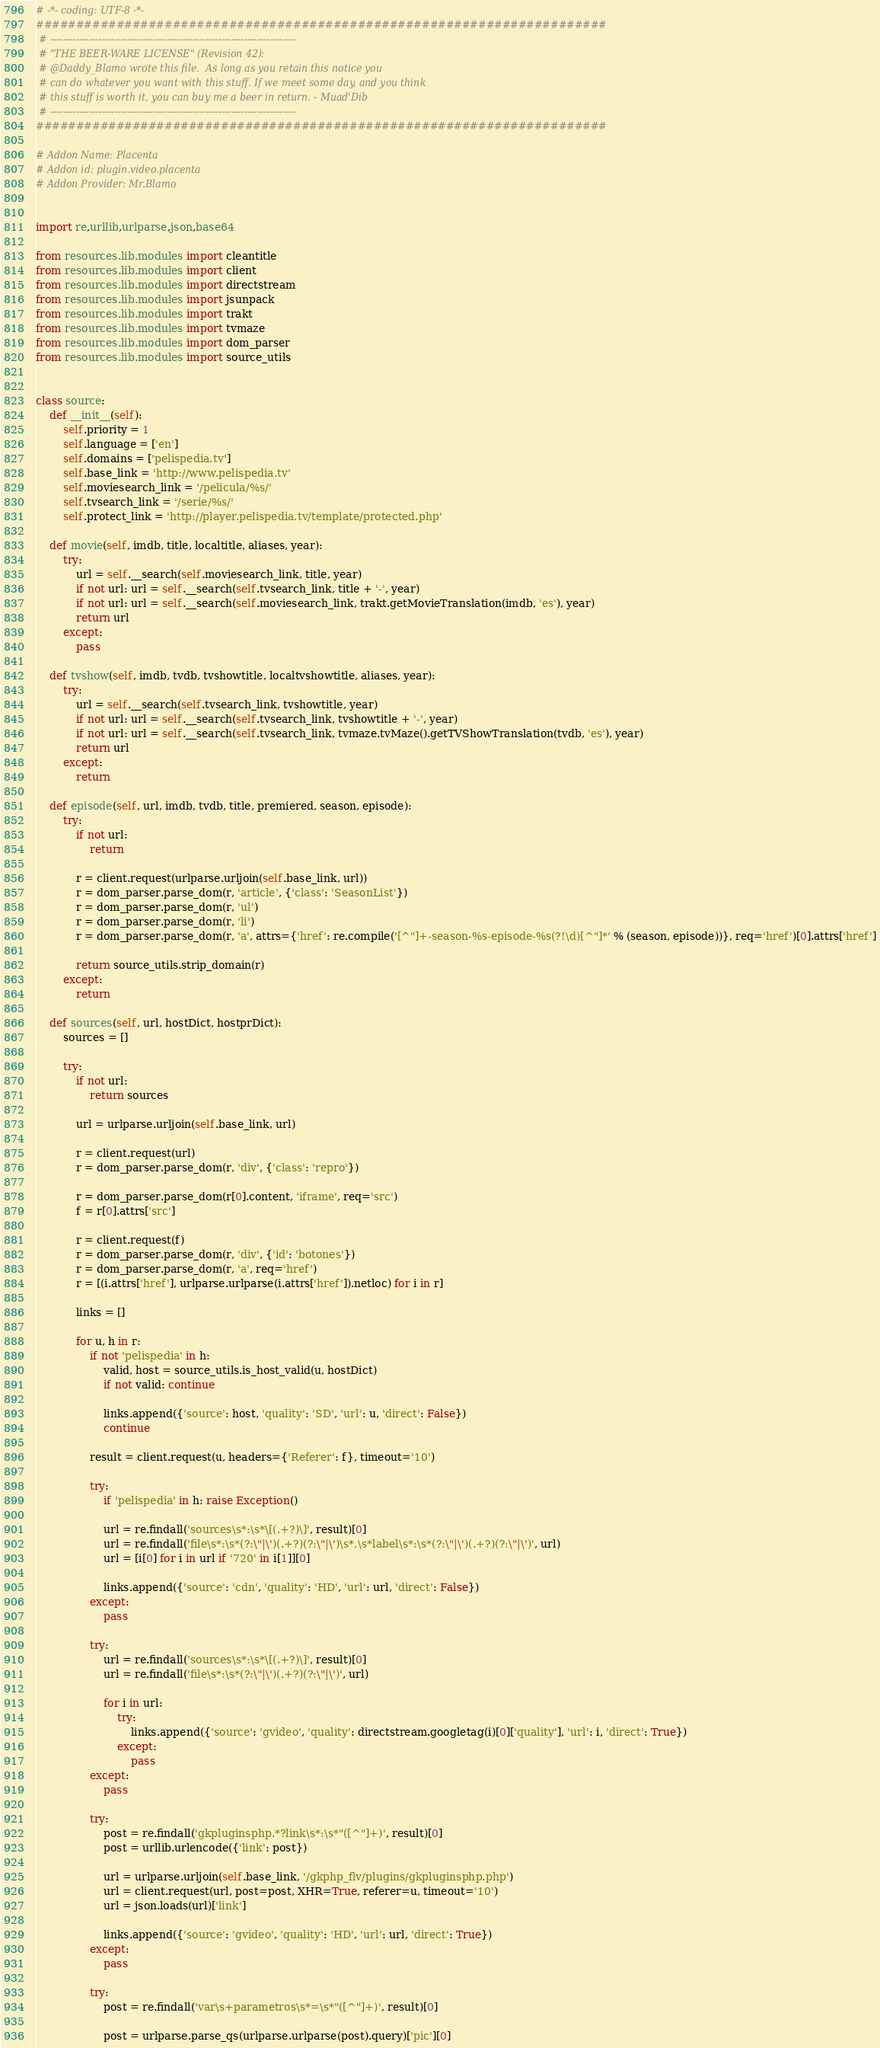Convert code to text. <code><loc_0><loc_0><loc_500><loc_500><_Python_># -*- coding: UTF-8 -*-
#######################################################################
 # ----------------------------------------------------------------------------
 # "THE BEER-WARE LICENSE" (Revision 42):
 # @Daddy_Blamo wrote this file.  As long as you retain this notice you
 # can do whatever you want with this stuff. If we meet some day, and you think
 # this stuff is worth it, you can buy me a beer in return. - Muad'Dib
 # ----------------------------------------------------------------------------
#######################################################################

# Addon Name: Placenta
# Addon id: plugin.video.placenta
# Addon Provider: Mr.Blamo


import re,urllib,urlparse,json,base64

from resources.lib.modules import cleantitle
from resources.lib.modules import client
from resources.lib.modules import directstream
from resources.lib.modules import jsunpack
from resources.lib.modules import trakt
from resources.lib.modules import tvmaze
from resources.lib.modules import dom_parser
from resources.lib.modules import source_utils


class source:
    def __init__(self):
        self.priority = 1
        self.language = ['en']
        self.domains = ['pelispedia.tv']
        self.base_link = 'http://www.pelispedia.tv'
        self.moviesearch_link = '/pelicula/%s/'
        self.tvsearch_link = '/serie/%s/'
        self.protect_link = 'http://player.pelispedia.tv/template/protected.php'

    def movie(self, imdb, title, localtitle, aliases, year):
        try:
            url = self.__search(self.moviesearch_link, title, year)
            if not url: url = self.__search(self.tvsearch_link, title + '-', year)
            if not url: url = self.__search(self.moviesearch_link, trakt.getMovieTranslation(imdb, 'es'), year)
            return url
        except:
            pass

    def tvshow(self, imdb, tvdb, tvshowtitle, localtvshowtitle, aliases, year):
        try:
            url = self.__search(self.tvsearch_link, tvshowtitle, year)
            if not url: url = self.__search(self.tvsearch_link, tvshowtitle + '-', year)
            if not url: url = self.__search(self.tvsearch_link, tvmaze.tvMaze().getTVShowTranslation(tvdb, 'es'), year)
            return url
        except:
            return

    def episode(self, url, imdb, tvdb, title, premiered, season, episode):
        try:
            if not url:
                return

            r = client.request(urlparse.urljoin(self.base_link, url))
            r = dom_parser.parse_dom(r, 'article', {'class': 'SeasonList'})
            r = dom_parser.parse_dom(r, 'ul')
            r = dom_parser.parse_dom(r, 'li')
            r = dom_parser.parse_dom(r, 'a', attrs={'href': re.compile('[^"]+-season-%s-episode-%s(?!\d)[^"]*' % (season, episode))}, req='href')[0].attrs['href']

            return source_utils.strip_domain(r)
        except:
            return

    def sources(self, url, hostDict, hostprDict):
        sources = []

        try:
            if not url:
                return sources

            url = urlparse.urljoin(self.base_link, url)

            r = client.request(url)
            r = dom_parser.parse_dom(r, 'div', {'class': 'repro'})

            r = dom_parser.parse_dom(r[0].content, 'iframe', req='src')
            f = r[0].attrs['src']

            r = client.request(f)
            r = dom_parser.parse_dom(r, 'div', {'id': 'botones'})
            r = dom_parser.parse_dom(r, 'a', req='href')
            r = [(i.attrs['href'], urlparse.urlparse(i.attrs['href']).netloc) for i in r]

            links = []

            for u, h in r:
                if not 'pelispedia' in h:
                    valid, host = source_utils.is_host_valid(u, hostDict)
                    if not valid: continue

                    links.append({'source': host, 'quality': 'SD', 'url': u, 'direct': False})
                    continue

                result = client.request(u, headers={'Referer': f}, timeout='10')

                try:
                    if 'pelispedia' in h: raise Exception()

                    url = re.findall('sources\s*:\s*\[(.+?)\]', result)[0]
                    url = re.findall('file\s*:\s*(?:\"|\')(.+?)(?:\"|\')\s*,\s*label\s*:\s*(?:\"|\')(.+?)(?:\"|\')', url)
                    url = [i[0] for i in url if '720' in i[1]][0]

                    links.append({'source': 'cdn', 'quality': 'HD', 'url': url, 'direct': False})
                except:
                    pass

                try:
                    url = re.findall('sources\s*:\s*\[(.+?)\]', result)[0]
                    url = re.findall('file\s*:\s*(?:\"|\')(.+?)(?:\"|\')', url)

                    for i in url:
                        try:
                            links.append({'source': 'gvideo', 'quality': directstream.googletag(i)[0]['quality'], 'url': i, 'direct': True})
                        except:
                            pass
                except:
                    pass

                try:
                    post = re.findall('gkpluginsphp.*?link\s*:\s*"([^"]+)', result)[0]
                    post = urllib.urlencode({'link': post})

                    url = urlparse.urljoin(self.base_link, '/gkphp_flv/plugins/gkpluginsphp.php')
                    url = client.request(url, post=post, XHR=True, referer=u, timeout='10')
                    url = json.loads(url)['link']

                    links.append({'source': 'gvideo', 'quality': 'HD', 'url': url, 'direct': True})
                except:
                    pass

                try:
                    post = re.findall('var\s+parametros\s*=\s*"([^"]+)', result)[0]

                    post = urlparse.parse_qs(urlparse.urlparse(post).query)['pic'][0]</code> 